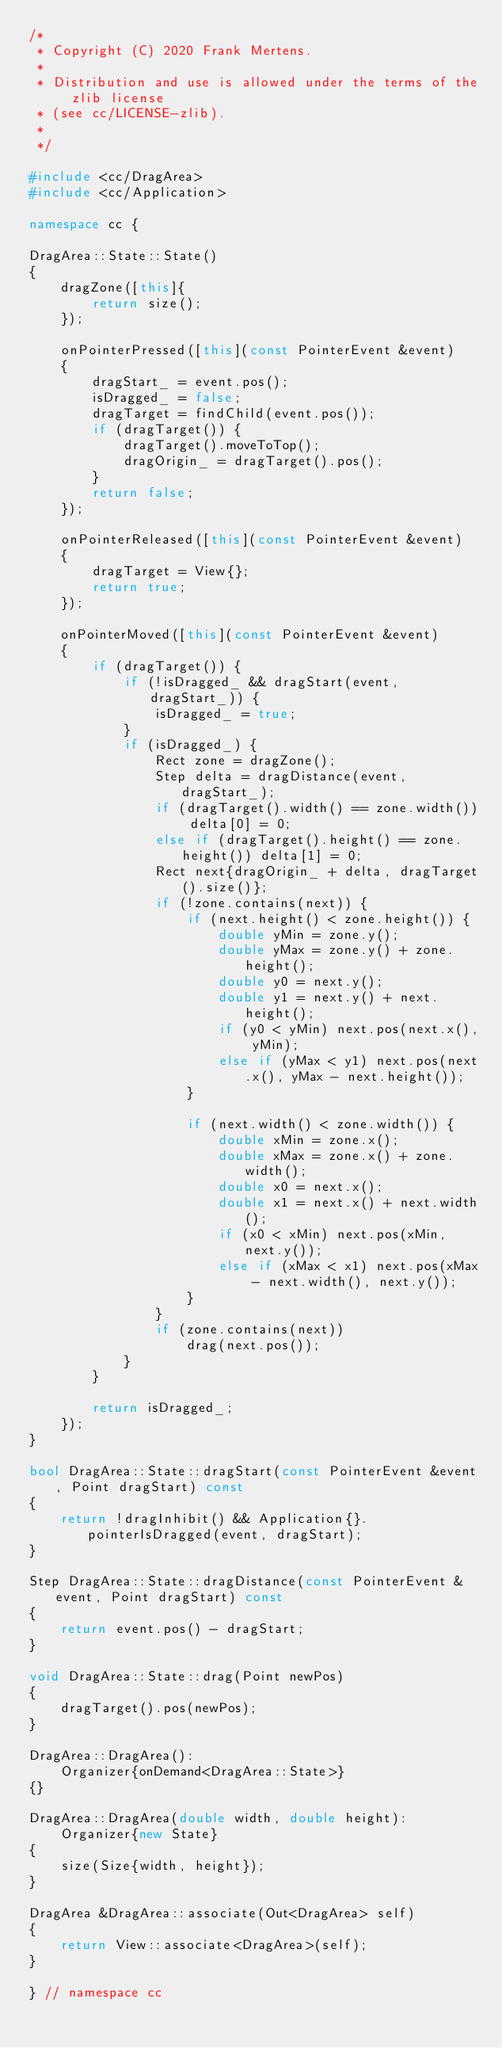Convert code to text. <code><loc_0><loc_0><loc_500><loc_500><_C++_>/*
 * Copyright (C) 2020 Frank Mertens.
 *
 * Distribution and use is allowed under the terms of the zlib license
 * (see cc/LICENSE-zlib).
 *
 */

#include <cc/DragArea>
#include <cc/Application>

namespace cc {

DragArea::State::State()
{
    dragZone([this]{
        return size();
    });

    onPointerPressed([this](const PointerEvent &event)
    {
        dragStart_ = event.pos();
        isDragged_ = false;
        dragTarget = findChild(event.pos());
        if (dragTarget()) {
            dragTarget().moveToTop();
            dragOrigin_ = dragTarget().pos();
        }
        return false;
    });

    onPointerReleased([this](const PointerEvent &event)
    {
        dragTarget = View{};
        return true;
    });

    onPointerMoved([this](const PointerEvent &event)
    {
        if (dragTarget()) {
            if (!isDragged_ && dragStart(event, dragStart_)) {
                isDragged_ = true;
            }
            if (isDragged_) {
                Rect zone = dragZone();
                Step delta = dragDistance(event, dragStart_);
                if (dragTarget().width() == zone.width()) delta[0] = 0;
                else if (dragTarget().height() == zone.height()) delta[1] = 0;
                Rect next{dragOrigin_ + delta, dragTarget().size()};
                if (!zone.contains(next)) {
                    if (next.height() < zone.height()) {
                        double yMin = zone.y();
                        double yMax = zone.y() + zone.height();
                        double y0 = next.y();
                        double y1 = next.y() + next.height();
                        if (y0 < yMin) next.pos(next.x(), yMin);
                        else if (yMax < y1) next.pos(next.x(), yMax - next.height());
                    }

                    if (next.width() < zone.width()) {
                        double xMin = zone.x();
                        double xMax = zone.x() + zone.width();
                        double x0 = next.x();
                        double x1 = next.x() + next.width();
                        if (x0 < xMin) next.pos(xMin, next.y());
                        else if (xMax < x1) next.pos(xMax - next.width(), next.y());
                    }
                }
                if (zone.contains(next))
                    drag(next.pos());
            }
        }

        return isDragged_;
    });
}

bool DragArea::State::dragStart(const PointerEvent &event, Point dragStart) const
{
    return !dragInhibit() && Application{}.pointerIsDragged(event, dragStart);
}

Step DragArea::State::dragDistance(const PointerEvent &event, Point dragStart) const
{
    return event.pos() - dragStart;
}

void DragArea::State::drag(Point newPos)
{
    dragTarget().pos(newPos);
}

DragArea::DragArea():
    Organizer{onDemand<DragArea::State>}
{}

DragArea::DragArea(double width, double height):
    Organizer{new State}
{
    size(Size{width, height});
}

DragArea &DragArea::associate(Out<DragArea> self)
{
    return View::associate<DragArea>(self);
}

} // namespace cc
</code> 